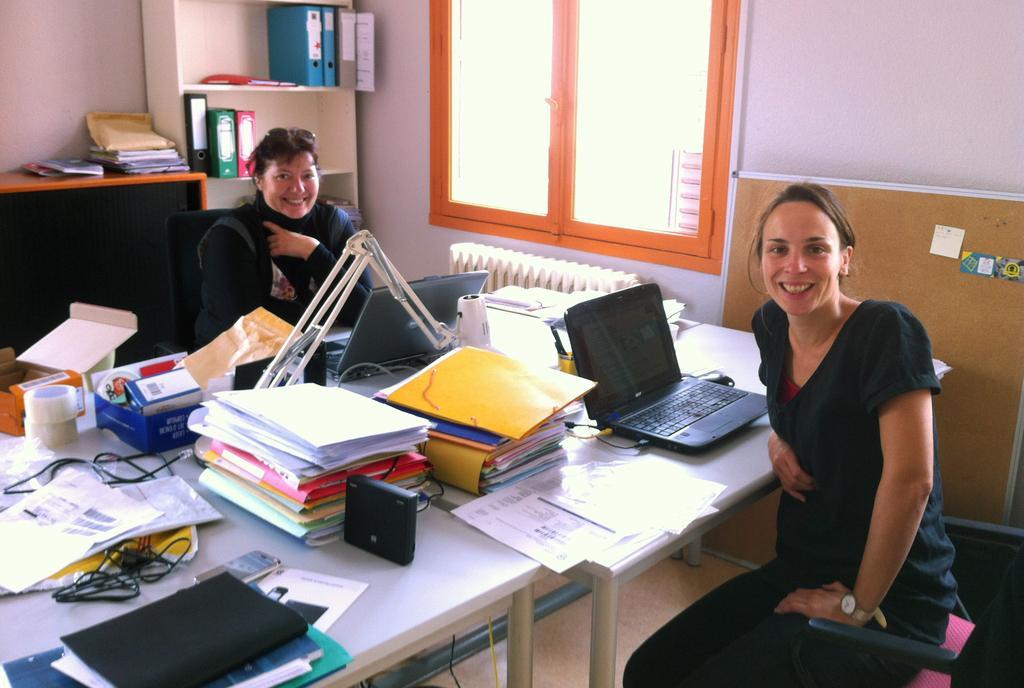Describe this image in one or two sentences. In this image we can see women sitting at the table. On the table we can see laptops, tapes, files, books, papers, wires and some objects. In the background we can see windows, files, cupboards, books and wall. 